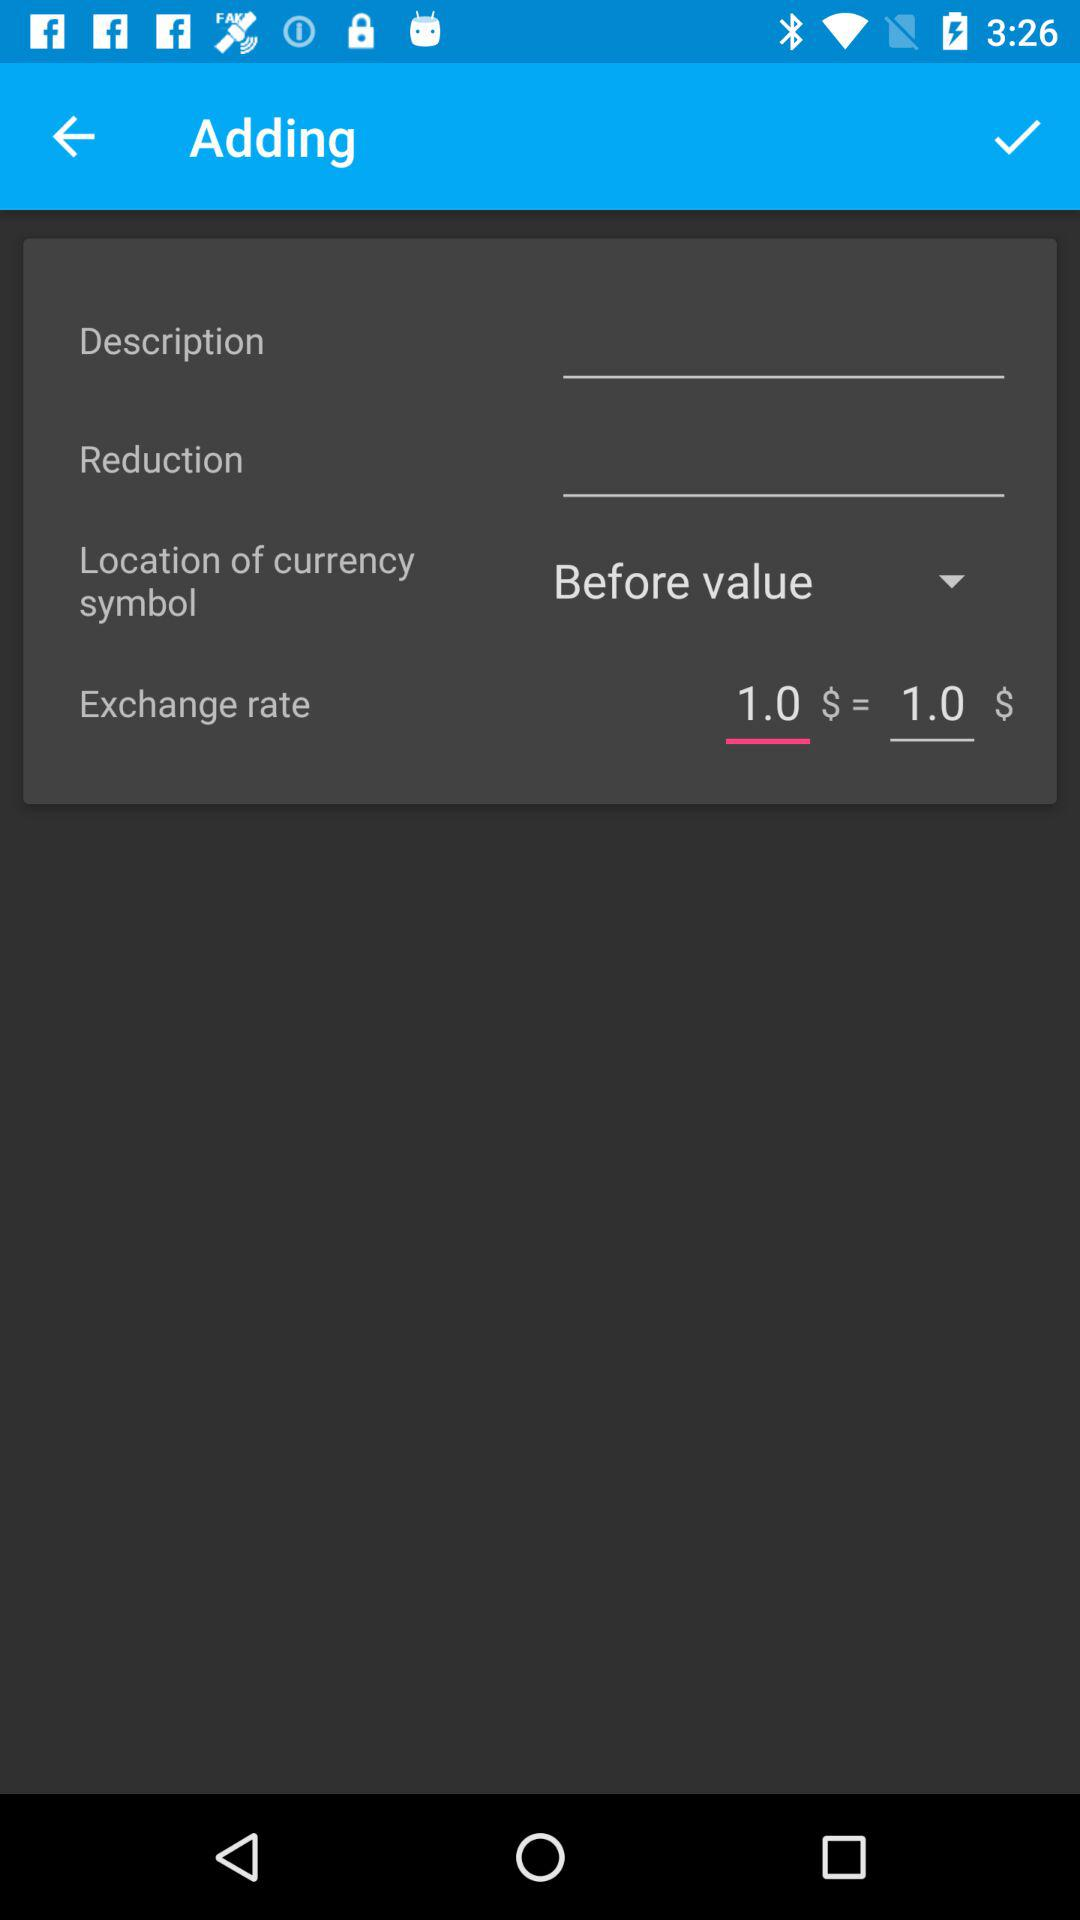What is the sum of the two exchange rates?
Answer the question using a single word or phrase. 2.0 